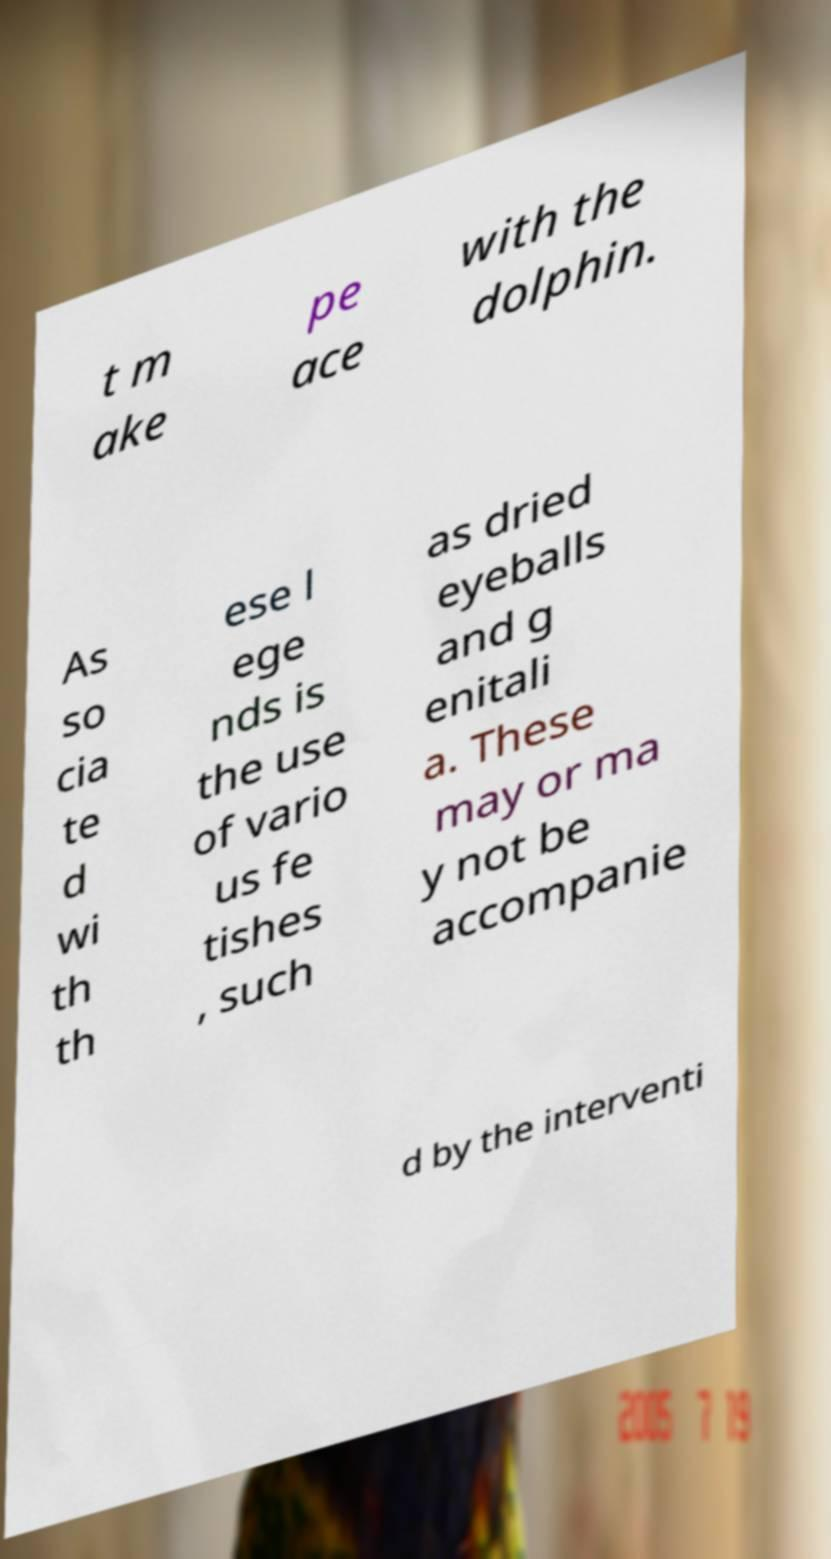Could you assist in decoding the text presented in this image and type it out clearly? t m ake pe ace with the dolphin. As so cia te d wi th th ese l ege nds is the use of vario us fe tishes , such as dried eyeballs and g enitali a. These may or ma y not be accompanie d by the interventi 